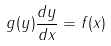Convert formula to latex. <formula><loc_0><loc_0><loc_500><loc_500>g ( y ) \frac { d y } { d x } = f ( x )</formula> 